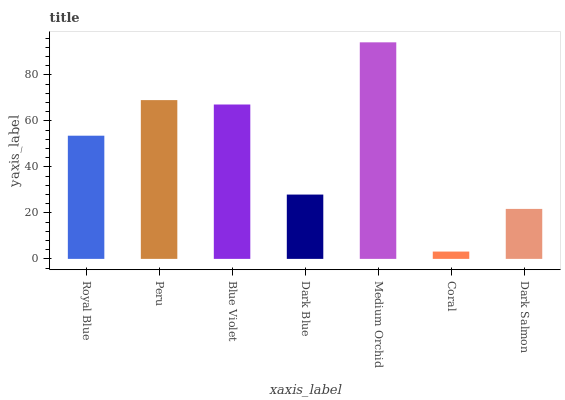Is Coral the minimum?
Answer yes or no. Yes. Is Medium Orchid the maximum?
Answer yes or no. Yes. Is Peru the minimum?
Answer yes or no. No. Is Peru the maximum?
Answer yes or no. No. Is Peru greater than Royal Blue?
Answer yes or no. Yes. Is Royal Blue less than Peru?
Answer yes or no. Yes. Is Royal Blue greater than Peru?
Answer yes or no. No. Is Peru less than Royal Blue?
Answer yes or no. No. Is Royal Blue the high median?
Answer yes or no. Yes. Is Royal Blue the low median?
Answer yes or no. Yes. Is Medium Orchid the high median?
Answer yes or no. No. Is Dark Blue the low median?
Answer yes or no. No. 